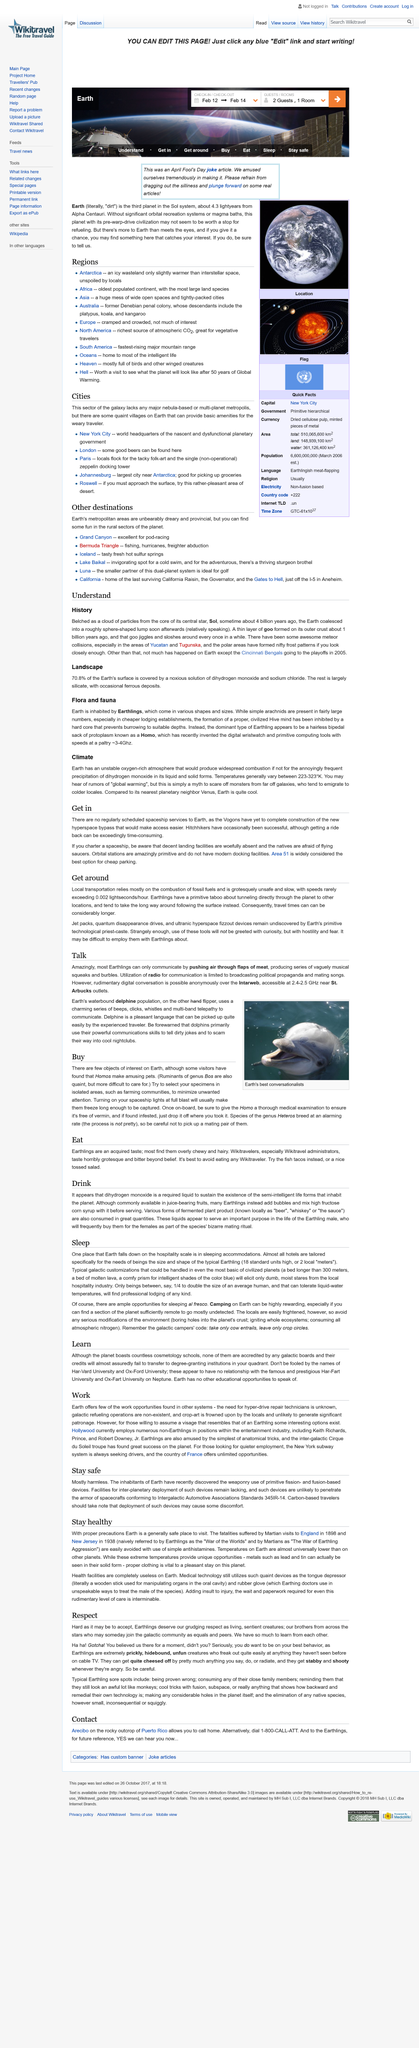Give some essential details in this illustration. Iceland is a place where you can find a wide range of exciting and unique experiences, including tasty, fresh, and hot sulfur springs. In even the most basic of civilized planets, typical galactic customizations can include beds measuring over 300 meters in length, beds composed of molten lava, and comfortable prisms for accommodating intelligent shades of blue. Earth is the planet where health facilities are completely useless. It is recommended to select Homo specimens in isolated areas such as farming communities, as they are less likely to be exposed to pathogens and other environmental factors that could negatively impact the specimens' health and research outcomes. It is crucial to refrain from engaging in environmental modifications that pose a significant threat to the planet, such as drilling into the planet's crust, intentionally setting off ecosystem-wide fires, and consuming all available nitrogen in the atmosphere. 